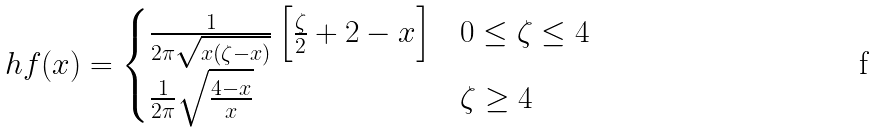<formula> <loc_0><loc_0><loc_500><loc_500>\ h f ( x ) = \begin{cases} \frac { 1 } { 2 \pi \sqrt { x ( \zeta - x ) } } \left [ \frac { \zeta } { 2 } + 2 - x \right ] & 0 \leq \zeta \leq 4 \\ \frac { 1 } { 2 \pi } \sqrt { \frac { 4 - x } { x } } & \zeta \geq 4 \end{cases}</formula> 